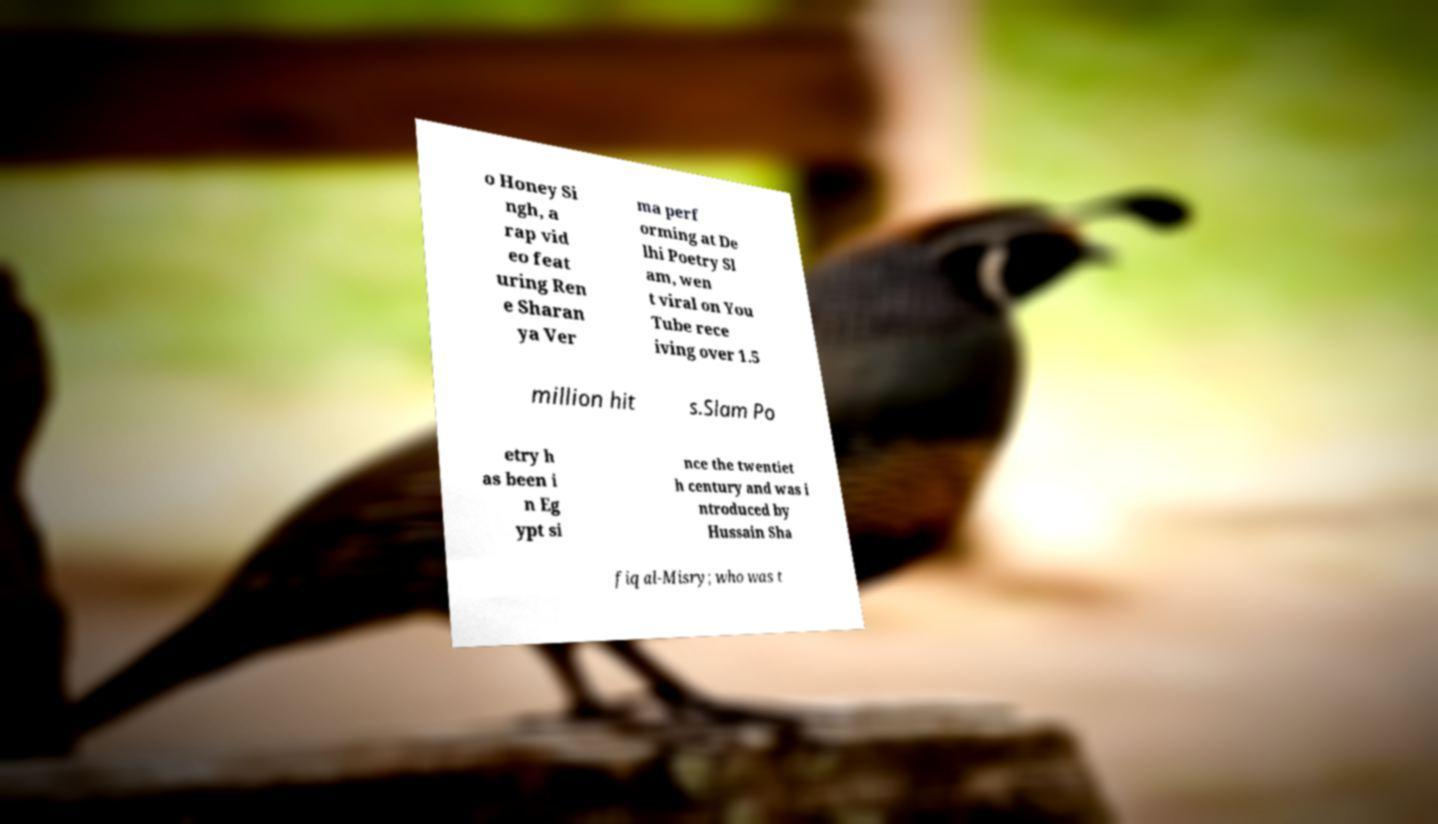There's text embedded in this image that I need extracted. Can you transcribe it verbatim? o Honey Si ngh, a rap vid eo feat uring Ren e Sharan ya Ver ma perf orming at De lhi Poetry Sl am, wen t viral on You Tube rece iving over 1.5 million hit s.Slam Po etry h as been i n Eg ypt si nce the twentiet h century and was i ntroduced by Hussain Sha fiq al-Misry; who was t 